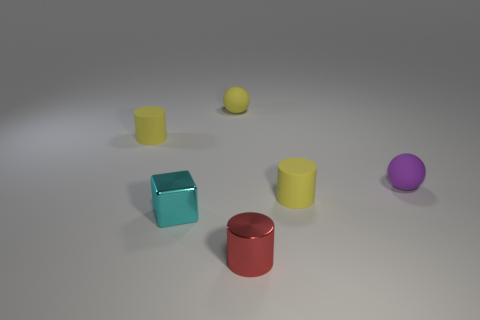Subtract all yellow blocks. How many yellow cylinders are left? 2 Subtract all matte cylinders. How many cylinders are left? 1 Add 2 yellow things. How many objects exist? 8 Add 3 cyan matte cylinders. How many cyan matte cylinders exist? 3 Subtract 0 blue balls. How many objects are left? 6 Subtract all blocks. How many objects are left? 5 Subtract all cyan rubber blocks. Subtract all cubes. How many objects are left? 5 Add 4 metal cylinders. How many metal cylinders are left? 5 